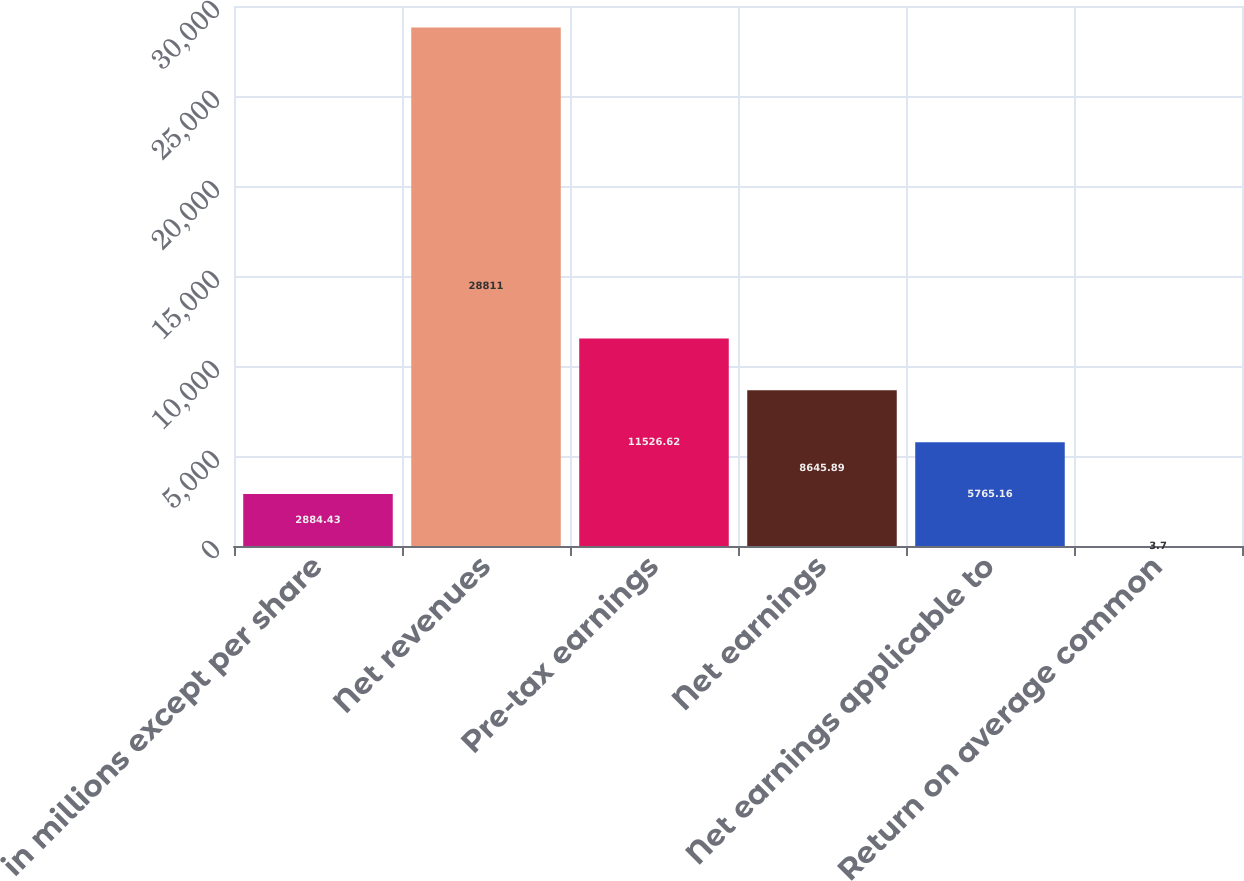Convert chart to OTSL. <chart><loc_0><loc_0><loc_500><loc_500><bar_chart><fcel>in millions except per share<fcel>Net revenues<fcel>Pre-tax earnings<fcel>Net earnings<fcel>Net earnings applicable to<fcel>Return on average common<nl><fcel>2884.43<fcel>28811<fcel>11526.6<fcel>8645.89<fcel>5765.16<fcel>3.7<nl></chart> 